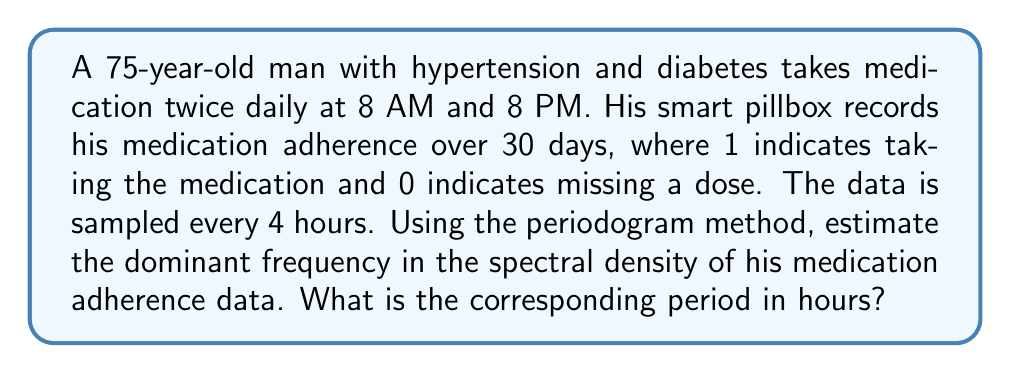Could you help me with this problem? To solve this problem, we'll follow these steps:

1) First, we need to understand the data:
   - Sampling frequency: Every 4 hours
   - Total duration: 30 days = 30 * 24 = 720 hours
   - Number of samples: 720 / 4 = 180 samples

2) To estimate the spectral density, we'll use the periodogram method:
   
   $$S_{xx}(f) = \frac{1}{N}|\sum_{n=0}^{N-1} x[n]e^{-j2\pi fn}|^2$$

   where $S_{xx}(f)$ is the spectral density, $N$ is the number of samples, and $x[n]$ is the time series data.

3) The dominant frequency will be the one with the highest peak in the periodogram.

4) Given the medication schedule (twice daily at 8 AM and 8 PM), we expect to see a dominant frequency corresponding to a 12-hour period.

5) To convert from frequency to period:
   
   $$T = \frac{1}{f}$$

   where $T$ is the period and $f$ is the frequency.

6) In this case, we expect:
   
   $$f_{dominant} = \frac{1}{12 \text{ hours}} = 0.0833 \text{ cycles/hour}$$

7) To convert this to the units of our sampling frequency (every 4 hours):
   
   $$f_{dominant} = 0.0833 \text{ cycles/hour} * 4 \text{ hours/sample} = 0.3333 \text{ cycles/sample}$$

8) This dominant frequency should appear as a peak in the periodogram.

9) To confirm the period, we calculate:
   
   $$T = \frac{1}{f_{dominant}} = \frac{1}{0.0833} = 12 \text{ hours}$$

Therefore, the dominant frequency in the spectral density corresponds to a period of 12 hours, matching the patient's twice-daily medication schedule.
Answer: 12 hours 